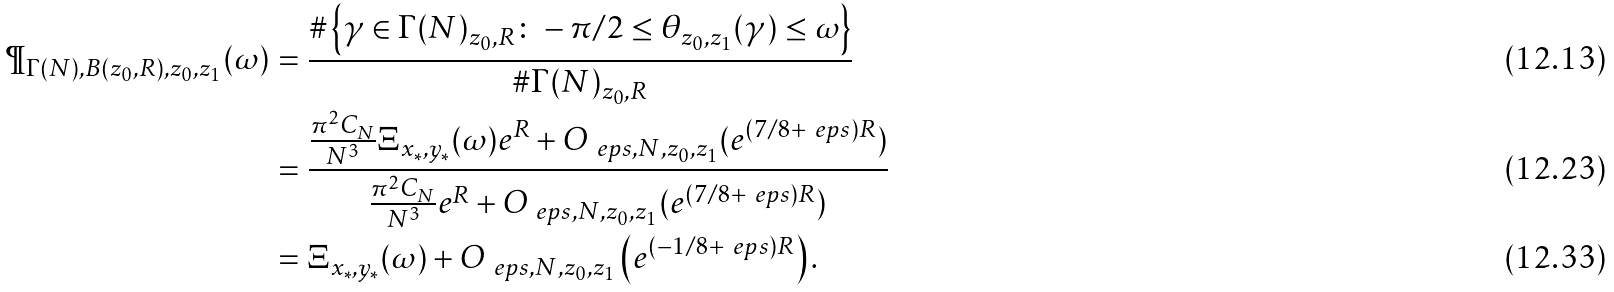<formula> <loc_0><loc_0><loc_500><loc_500>\P _ { \Gamma ( N ) , B ( z _ { 0 } , R ) , z _ { 0 } , z _ { 1 } } ( \omega ) & = \frac { \# \left \{ \gamma \in \Gamma ( N ) _ { z _ { 0 } , R } \colon - \pi / 2 \leq \theta _ { z _ { 0 } , z _ { 1 } } ( \gamma ) \leq \omega \right \} } { \# \Gamma ( N ) _ { z _ { 0 } , R } } \\ & = \frac { \frac { \pi ^ { 2 } C _ { N } } { N ^ { 3 } } \Xi _ { x _ { * } , y _ { * } } ( \omega ) e ^ { R } + O _ { \ e p s , N , z _ { 0 } , z _ { 1 } } ( e ^ { ( 7 / 8 + \ e p s ) R } ) } { \frac { \pi ^ { 2 } C _ { N } } { N ^ { 3 } } e ^ { R } + O _ { \ e p s , N , z _ { 0 } , z _ { 1 } } ( e ^ { ( 7 / 8 + \ e p s ) R } ) } \\ & = \Xi _ { x _ { * } , y _ { * } } ( \omega ) + O _ { \ e p s , N , z _ { 0 } , z _ { 1 } } \left ( e ^ { ( - 1 / 8 + \ e p s ) R } \right ) .</formula> 